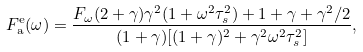Convert formula to latex. <formula><loc_0><loc_0><loc_500><loc_500>F _ { \text {a} } ^ { \text {e} } ( \omega ) = \frac { F _ { \omega } ( 2 + \gamma ) \gamma ^ { 2 } ( 1 + \omega ^ { 2 } \tau _ { s } ^ { 2 } ) + 1 + \gamma + \gamma ^ { 2 } / 2 } { ( 1 + \gamma ) [ ( 1 + \gamma ) ^ { 2 } + \gamma ^ { 2 } \omega ^ { 2 } \tau _ { s } ^ { 2 } ] } ,</formula> 